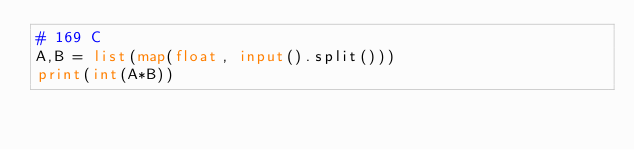<code> <loc_0><loc_0><loc_500><loc_500><_Python_># 169 C
A,B = list(map(float, input().split()))
print(int(A*B))</code> 